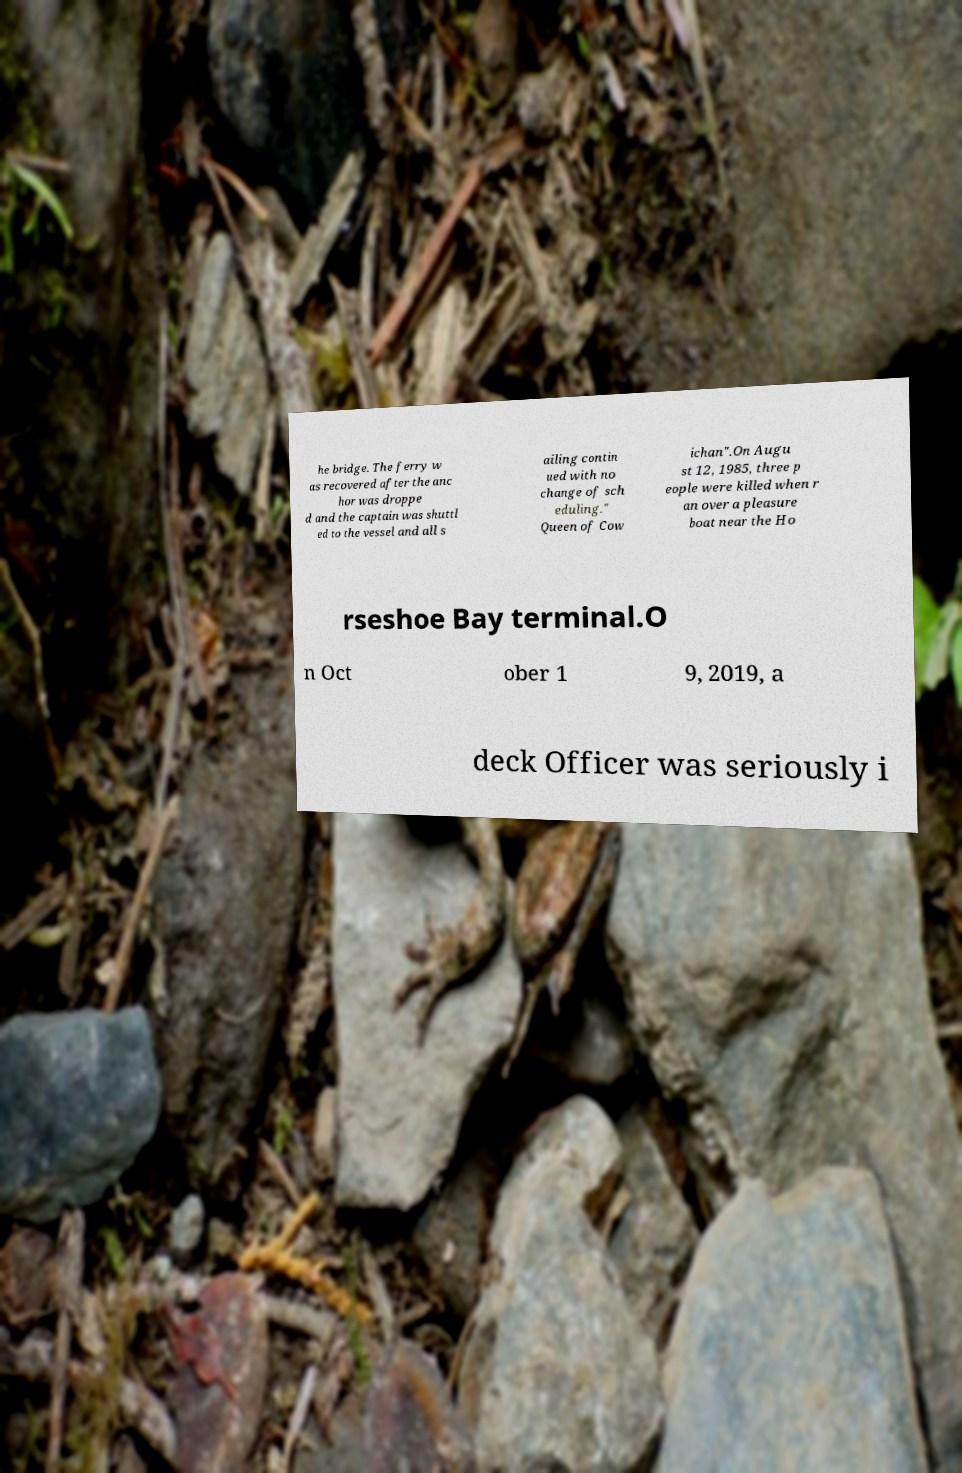Can you read and provide the text displayed in the image?This photo seems to have some interesting text. Can you extract and type it out for me? he bridge. The ferry w as recovered after the anc hor was droppe d and the captain was shuttl ed to the vessel and all s ailing contin ued with no change of sch eduling." Queen of Cow ichan".On Augu st 12, 1985, three p eople were killed when r an over a pleasure boat near the Ho rseshoe Bay terminal.O n Oct ober 1 9, 2019, a deck Officer was seriously i 